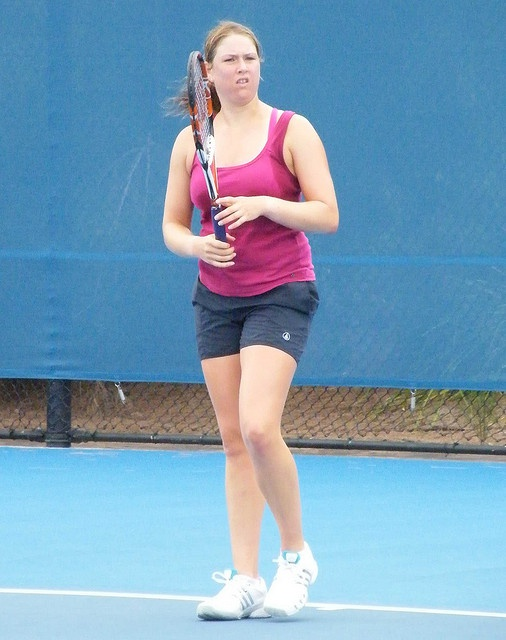Describe the objects in this image and their specific colors. I can see people in gray, lightgray, tan, and purple tones and tennis racket in gray, lightgray, darkgray, and brown tones in this image. 